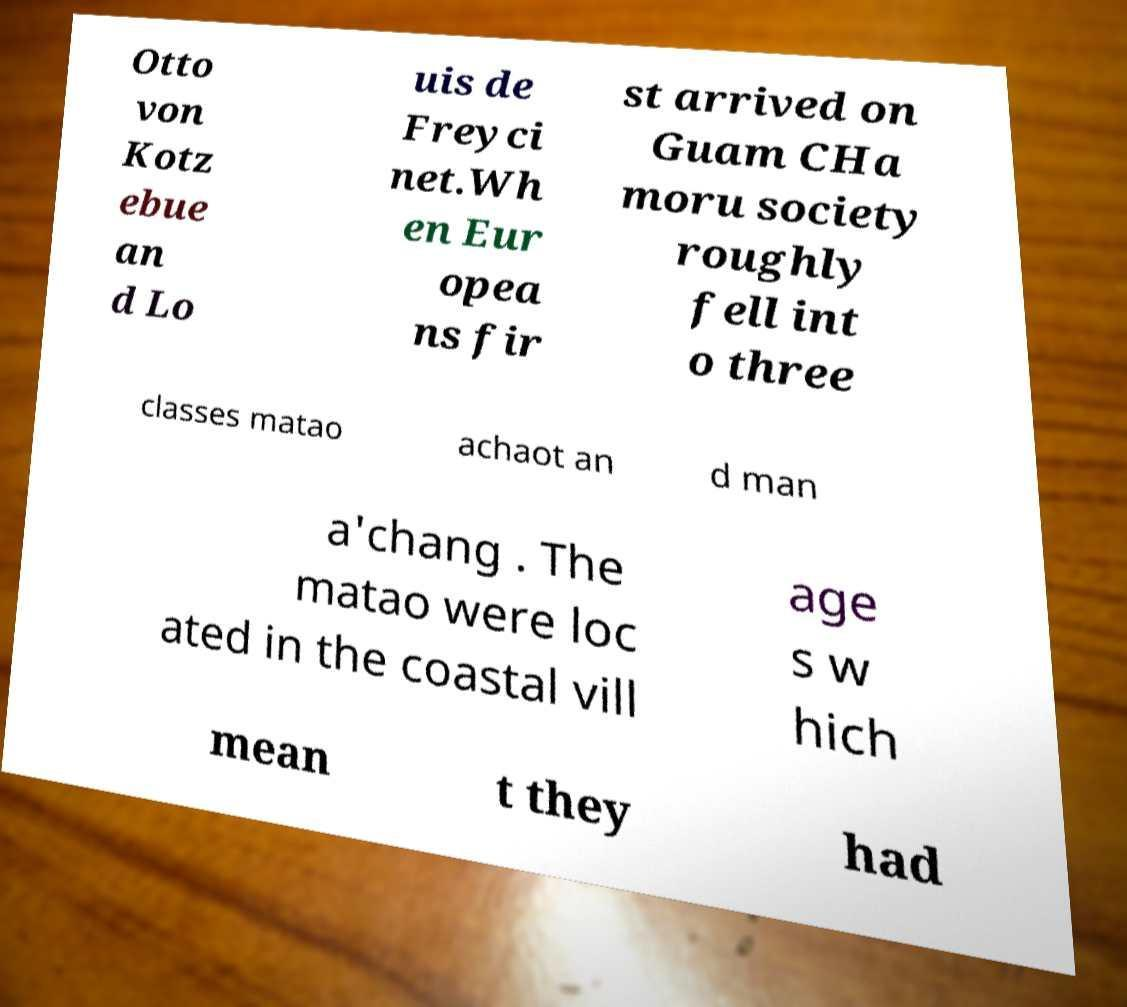Can you read and provide the text displayed in the image?This photo seems to have some interesting text. Can you extract and type it out for me? Otto von Kotz ebue an d Lo uis de Freyci net.Wh en Eur opea ns fir st arrived on Guam CHa moru society roughly fell int o three classes matao achaot an d man a'chang . The matao were loc ated in the coastal vill age s w hich mean t they had 